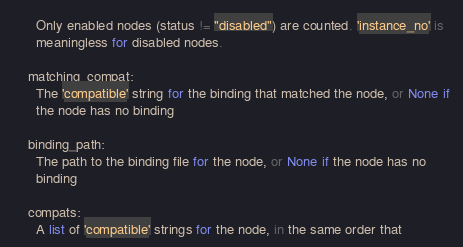<code> <loc_0><loc_0><loc_500><loc_500><_Python_>      Only enabled nodes (status != "disabled") are counted. 'instance_no' is
      meaningless for disabled nodes.

    matching_compat:
      The 'compatible' string for the binding that matched the node, or None if
      the node has no binding

    binding_path:
      The path to the binding file for the node, or None if the node has no
      binding

    compats:
      A list of 'compatible' strings for the node, in the same order that</code> 